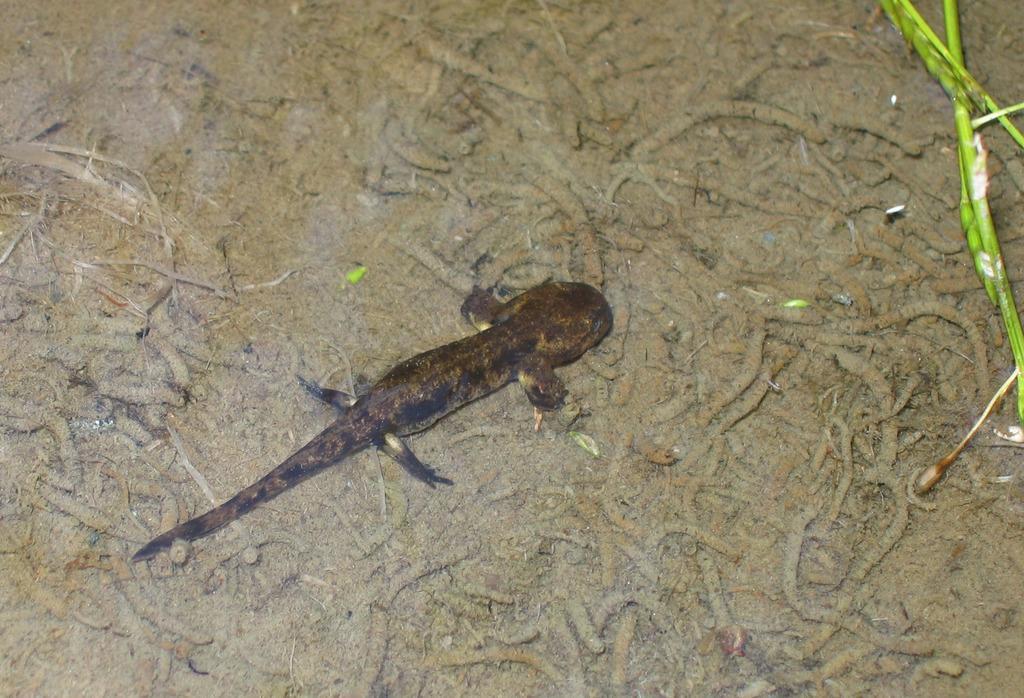Can you describe this image briefly? In this picture we can see a lizard and salamanders on the ground. 